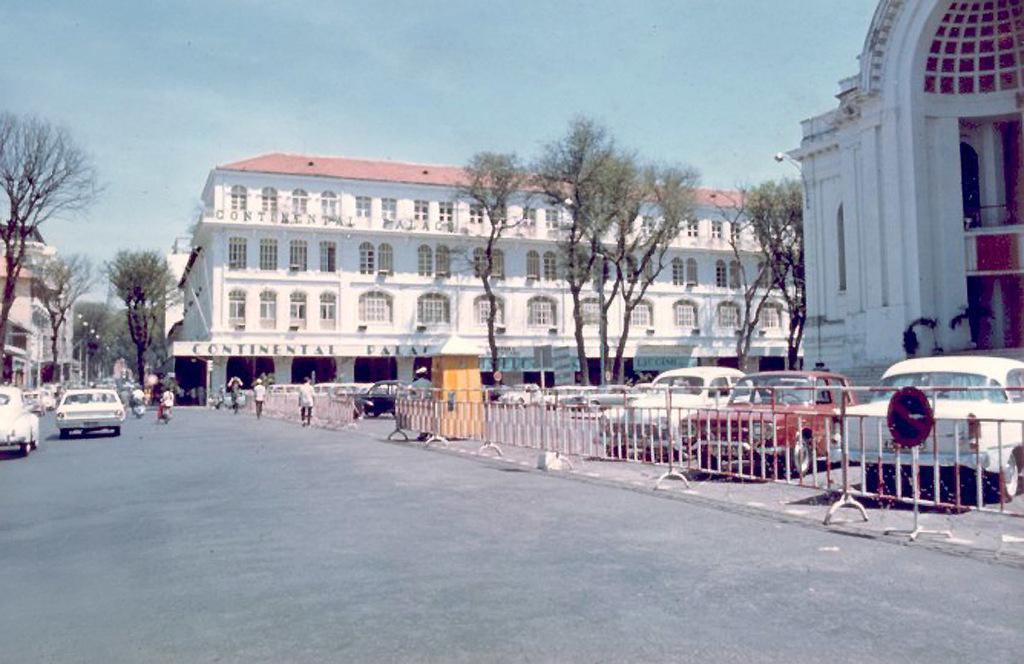In one or two sentences, can you explain what this image depicts? This is a picture of a city , where there are iron grills, sign board, buildings, trees , poles, lights, group of people, vehicles on the road, and in the background there is sky. 